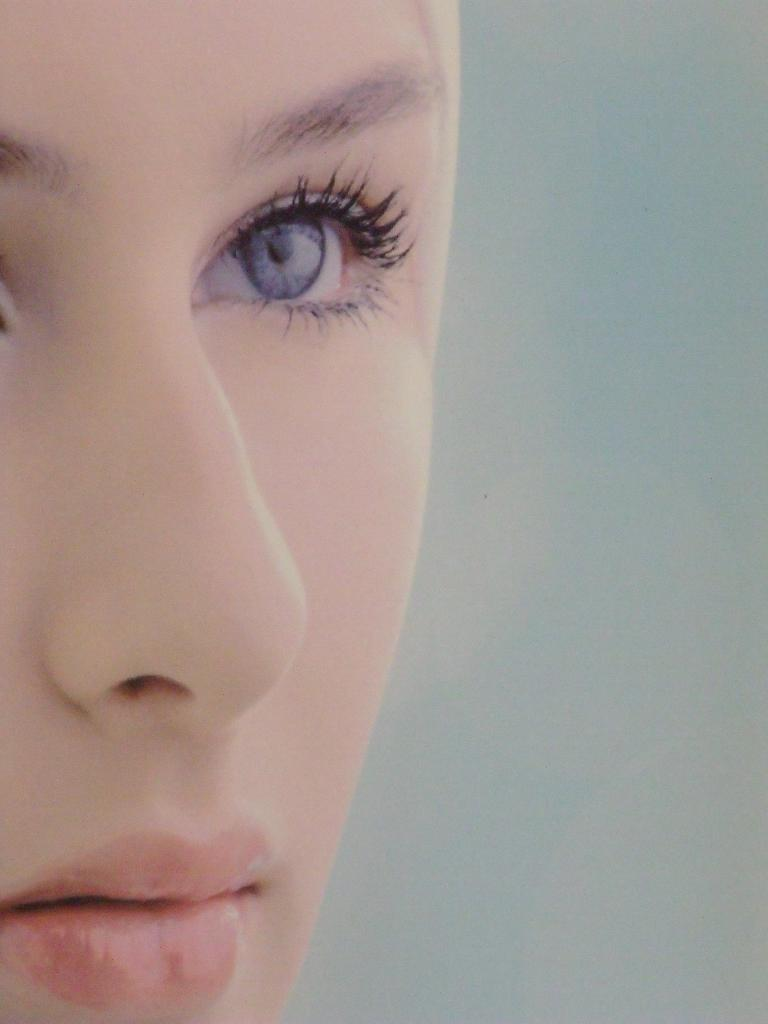What is the main subject of the image? The main subject of the image is a truncated woman. What type of company is depicted in the image? There is no company depicted in the image; it features a truncated woman. What territory is shown in the image? There is no territory shown in the image; it features a truncated woman. 